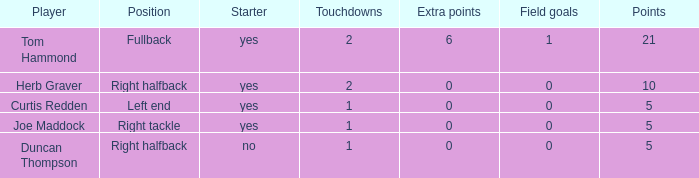What is the number of points for field goals worth 1? 1.0. 